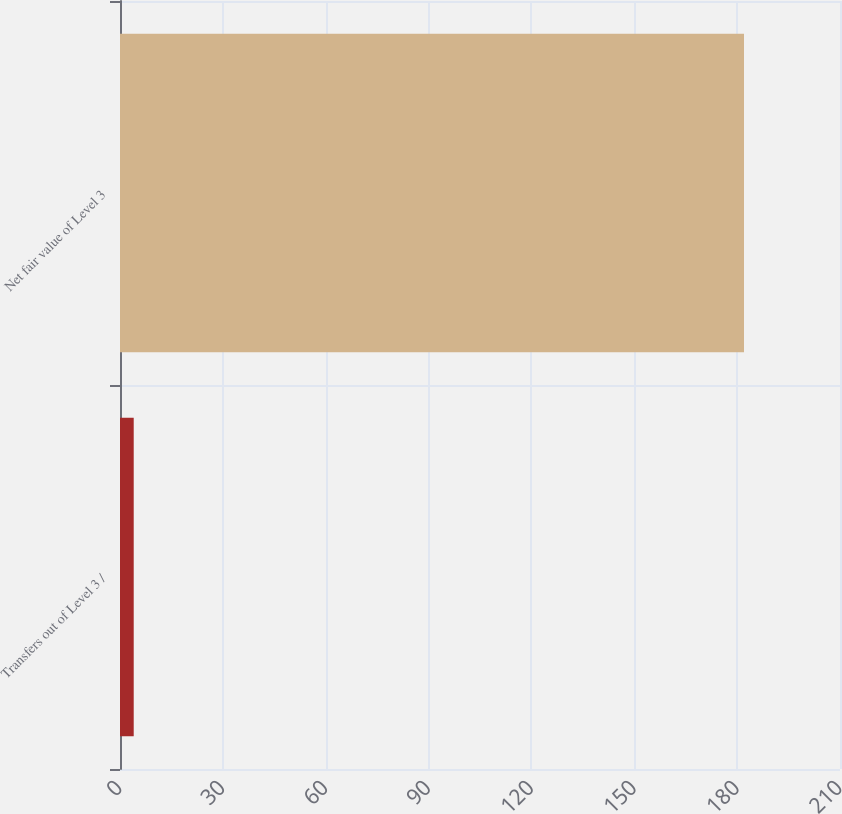Convert chart. <chart><loc_0><loc_0><loc_500><loc_500><bar_chart><fcel>Transfers out of Level 3 /<fcel>Net fair value of Level 3<nl><fcel>4<fcel>182<nl></chart> 